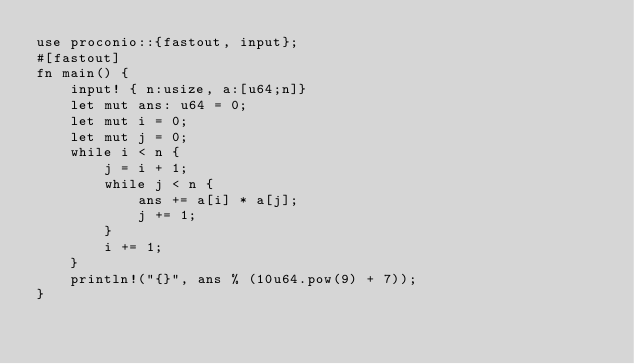<code> <loc_0><loc_0><loc_500><loc_500><_Rust_>use proconio::{fastout, input};
#[fastout]
fn main() {
    input! { n:usize, a:[u64;n]}
    let mut ans: u64 = 0;
    let mut i = 0;
    let mut j = 0;
    while i < n {
        j = i + 1;
        while j < n {
            ans += a[i] * a[j];
            j += 1;
        }
        i += 1;
    }
    println!("{}", ans % (10u64.pow(9) + 7));
}
</code> 